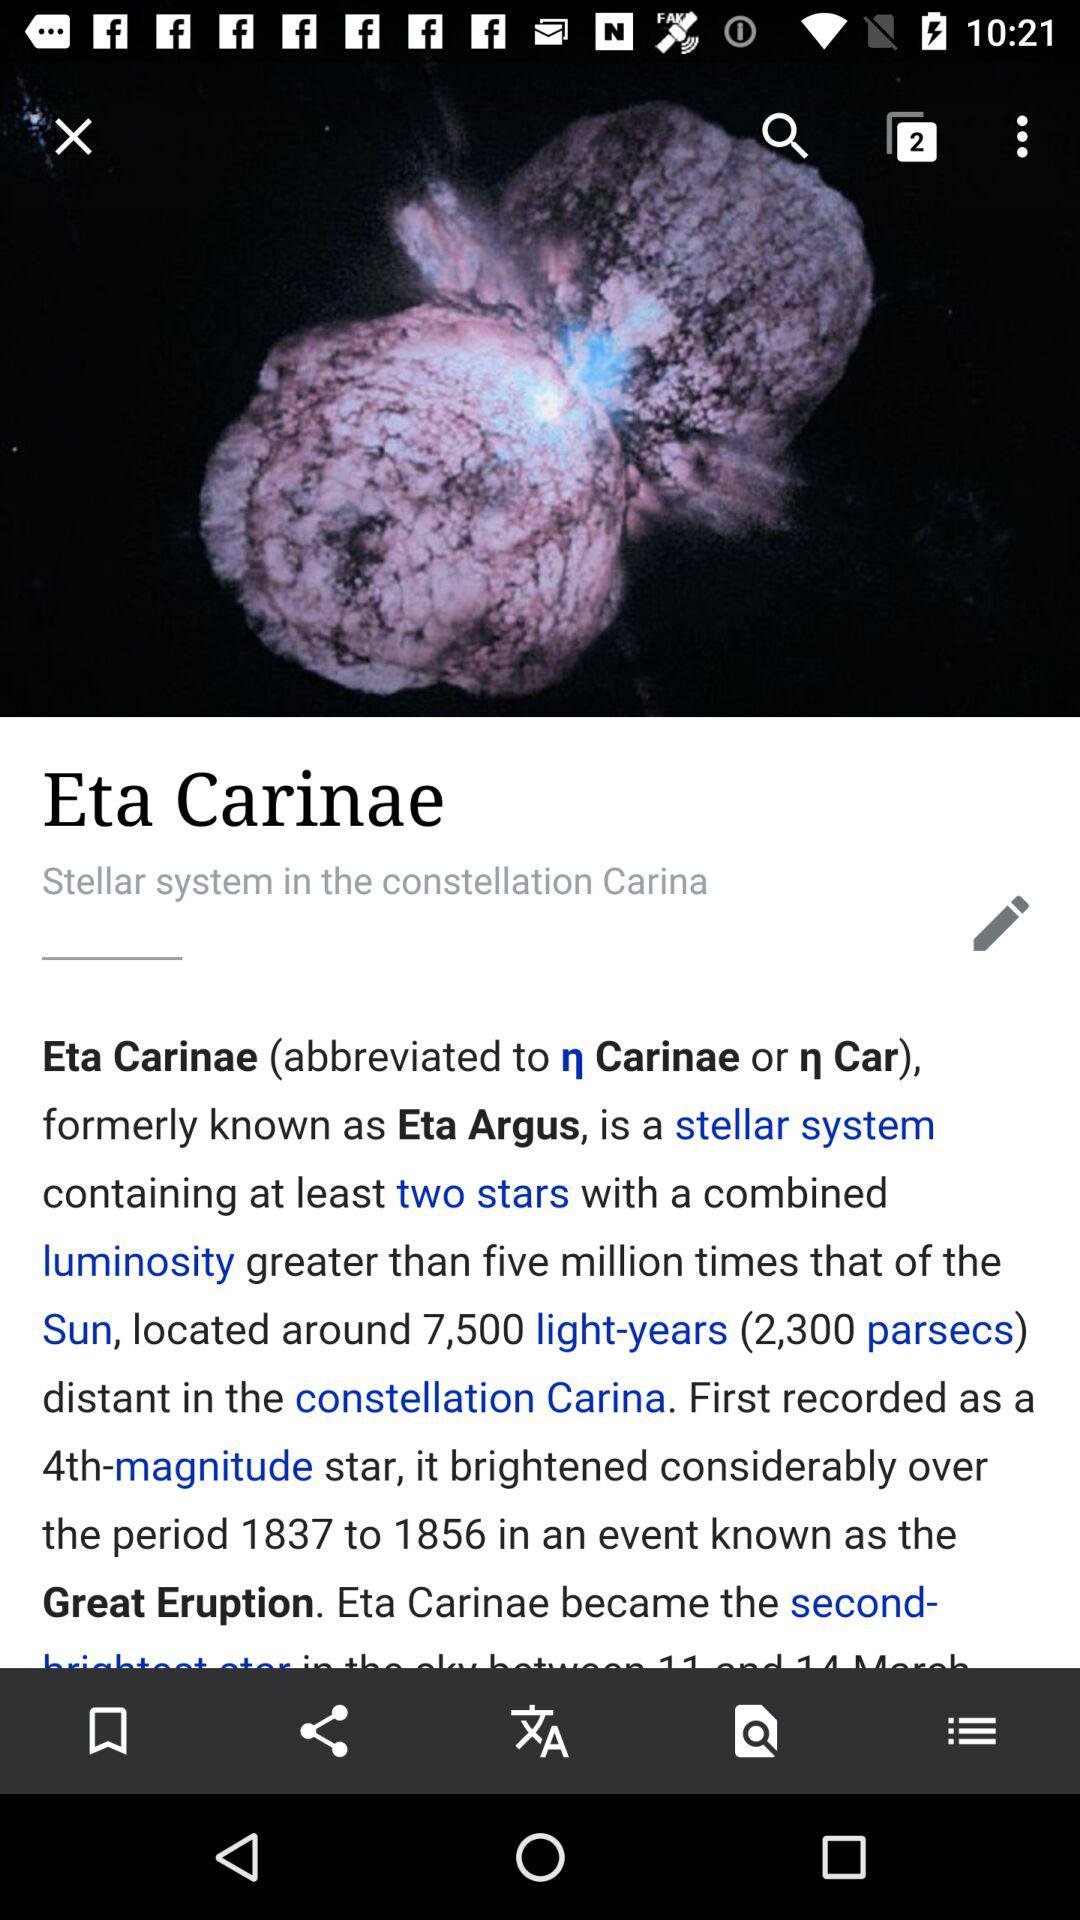What is the first recorded as a 4th magnitude star? The first recorded as a 4th magnitude star is Eta Carinae. 